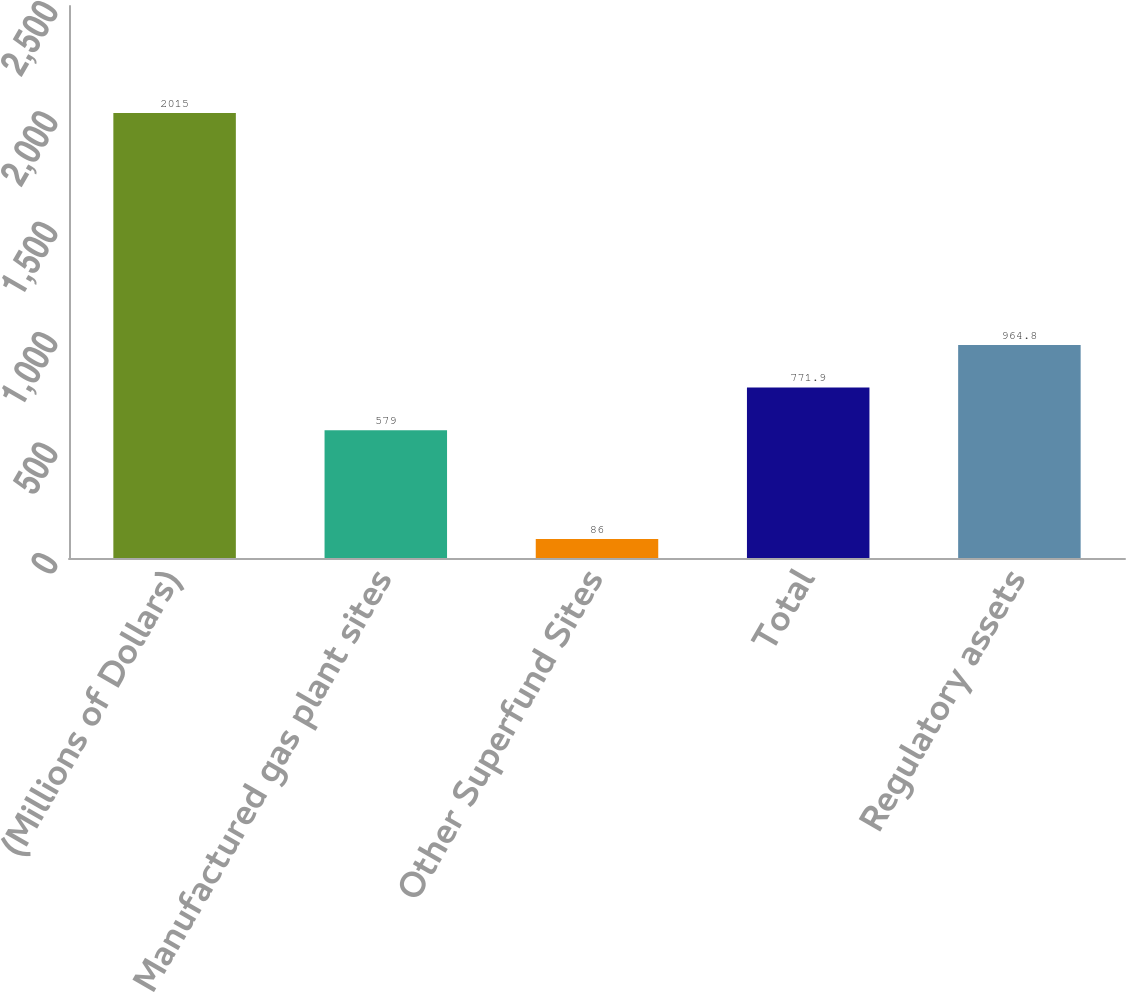<chart> <loc_0><loc_0><loc_500><loc_500><bar_chart><fcel>(Millions of Dollars)<fcel>Manufactured gas plant sites<fcel>Other Superfund Sites<fcel>Total<fcel>Regulatory assets<nl><fcel>2015<fcel>579<fcel>86<fcel>771.9<fcel>964.8<nl></chart> 